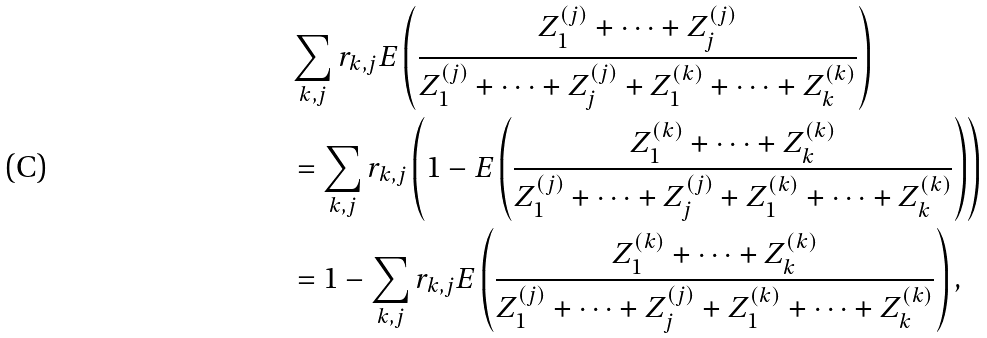<formula> <loc_0><loc_0><loc_500><loc_500>& \sum _ { k , j } r _ { k , j } E \left ( \frac { Z _ { 1 } ^ { ( j ) } + \cdots + Z _ { j } ^ { ( j ) } } { Z _ { 1 } ^ { ( j ) } + \cdots + Z _ { j } ^ { ( j ) } + Z _ { 1 } ^ { ( k ) } + \cdots + Z _ { k } ^ { ( k ) } } \right ) \\ & = \sum _ { k , j } r _ { k , j } \left ( 1 - E \left ( \frac { Z _ { 1 } ^ { ( k ) } + \cdots + Z _ { k } ^ { ( k ) } } { Z _ { 1 } ^ { ( j ) } + \cdots + Z _ { j } ^ { ( j ) } + Z _ { 1 } ^ { ( k ) } + \cdots + Z _ { k } ^ { ( k ) } } \right ) \right ) \\ & = 1 - \sum _ { k , j } r _ { k , j } E \left ( \frac { Z _ { 1 } ^ { ( k ) } + \cdots + Z _ { k } ^ { ( k ) } } { Z _ { 1 } ^ { ( j ) } + \cdots + Z _ { j } ^ { ( j ) } + Z _ { 1 } ^ { ( k ) } + \cdots + Z _ { k } ^ { ( k ) } } \right ) ,</formula> 